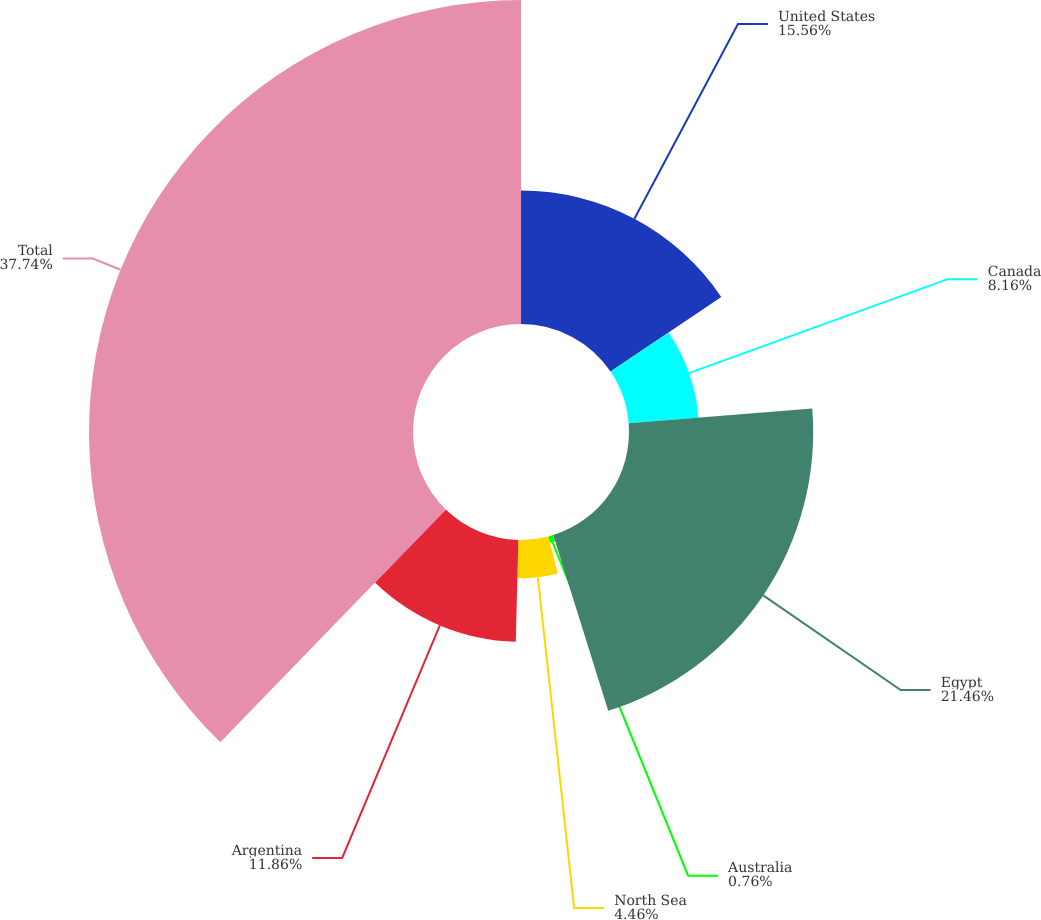Convert chart to OTSL. <chart><loc_0><loc_0><loc_500><loc_500><pie_chart><fcel>United States<fcel>Canada<fcel>Egypt<fcel>Australia<fcel>North Sea<fcel>Argentina<fcel>Total<nl><fcel>15.56%<fcel>8.16%<fcel>21.46%<fcel>0.76%<fcel>4.46%<fcel>11.86%<fcel>37.75%<nl></chart> 